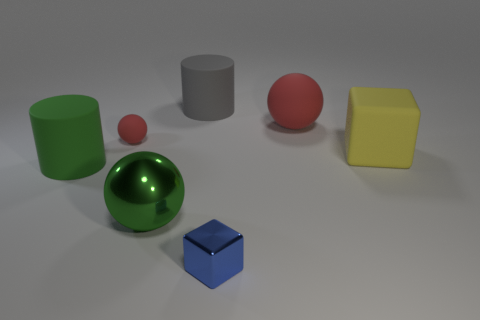Add 2 tiny green matte spheres. How many objects exist? 9 Subtract all balls. How many objects are left? 4 Add 1 big green rubber cylinders. How many big green rubber cylinders are left? 2 Add 2 large cyan shiny cylinders. How many large cyan shiny cylinders exist? 2 Subtract 0 red cylinders. How many objects are left? 7 Subtract all green cylinders. Subtract all large red rubber things. How many objects are left? 5 